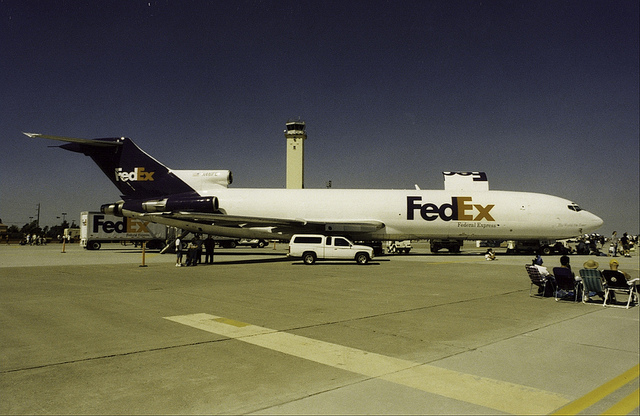<image>What 16 letter word is on the plane? I don't know the 16 letter word on the plane. It could be 'federal express' or 'fedex'. What 16 letter word is on the plane? I am not sure what is the 16 letter word on the plane. However, it can be seen 'Federal Express' or 'FedEx'. 